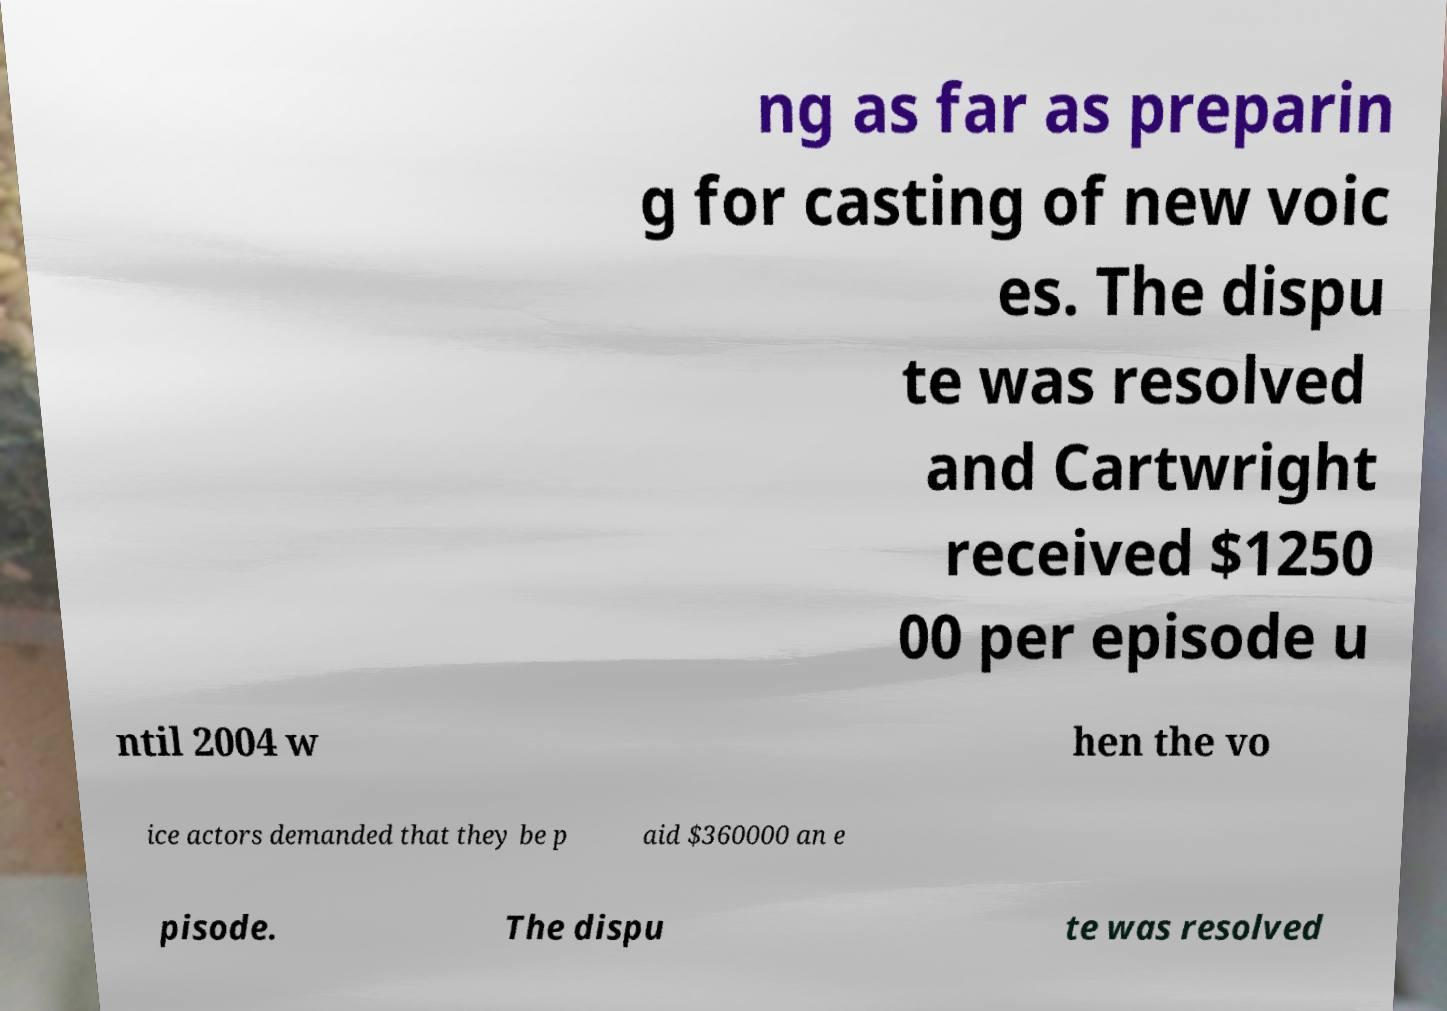I need the written content from this picture converted into text. Can you do that? ng as far as preparin g for casting of new voic es. The dispu te was resolved and Cartwright received $1250 00 per episode u ntil 2004 w hen the vo ice actors demanded that they be p aid $360000 an e pisode. The dispu te was resolved 